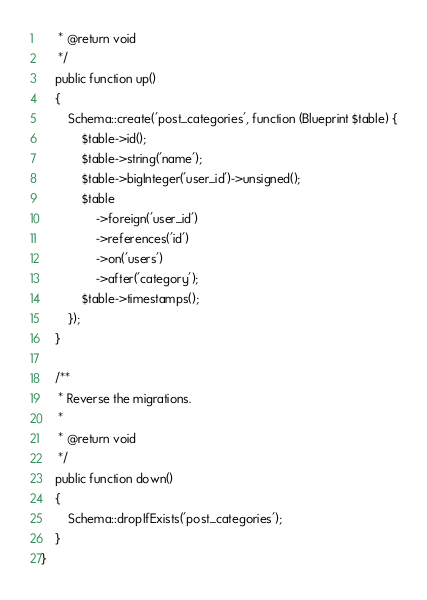<code> <loc_0><loc_0><loc_500><loc_500><_PHP_>     * @return void
     */
    public function up()
    {
        Schema::create('post_categories', function (Blueprint $table) {
            $table->id();
            $table->string('name');
            $table->bigInteger('user_id')->unsigned();
            $table
                ->foreign('user_id')
                ->references('id')
                ->on('users')
                ->after('category');
            $table->timestamps();
        });
    }

    /**
     * Reverse the migrations.
     *
     * @return void
     */
    public function down()
    {
        Schema::dropIfExists('post_categories');
    }
}
</code> 